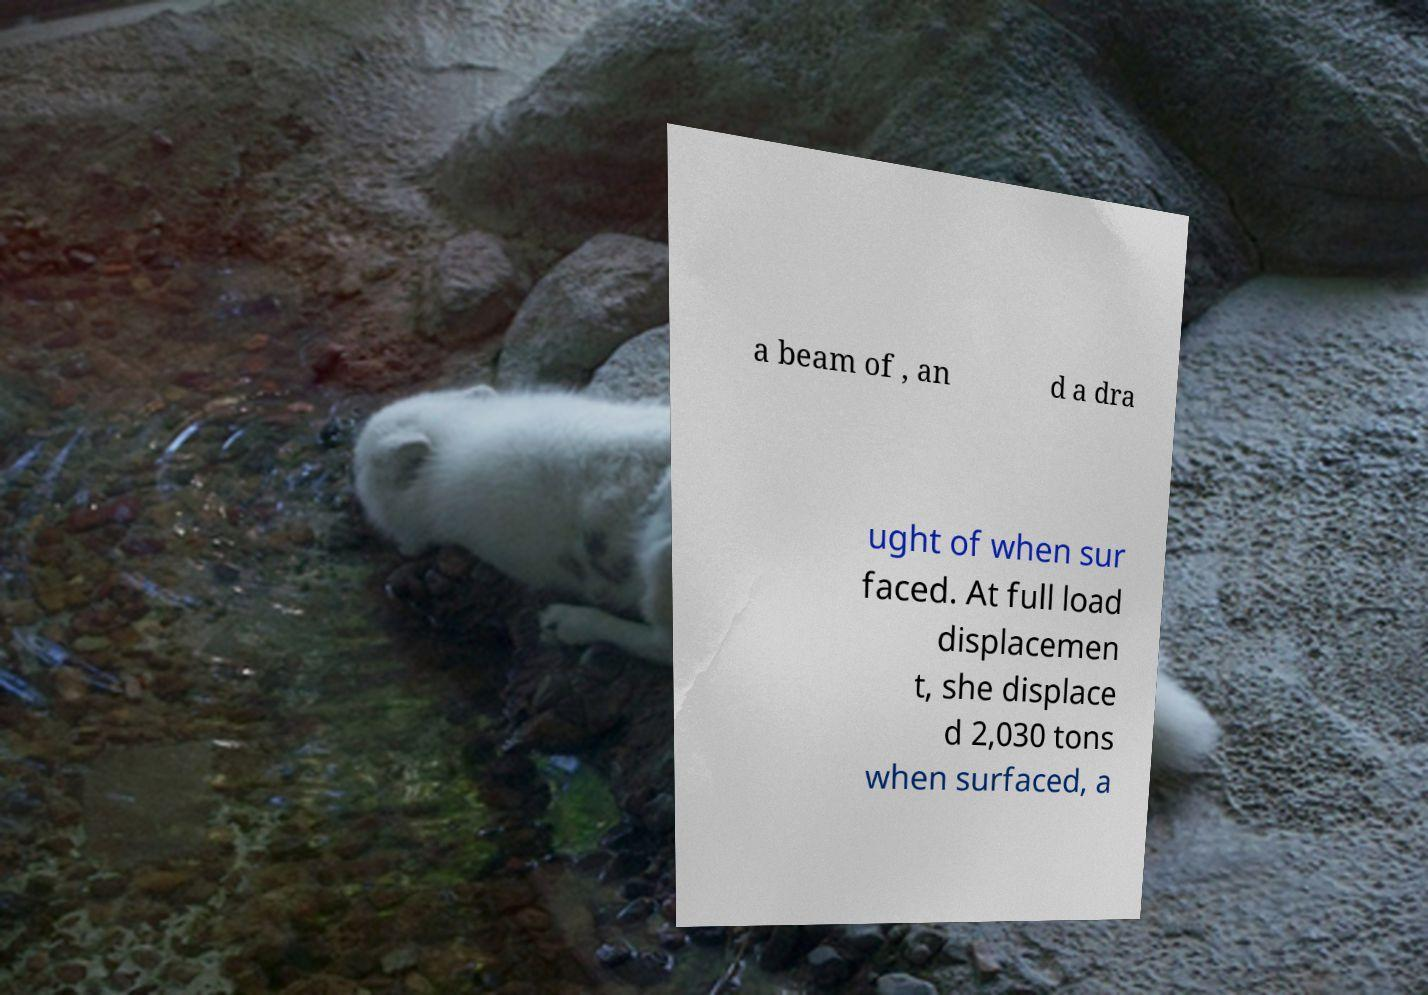What messages or text are displayed in this image? I need them in a readable, typed format. a beam of , an d a dra ught of when sur faced. At full load displacemen t, she displace d 2,030 tons when surfaced, a 